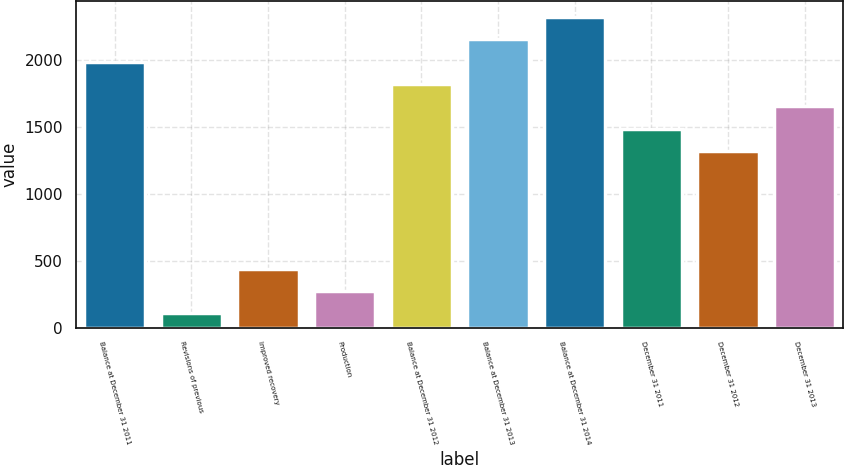Convert chart to OTSL. <chart><loc_0><loc_0><loc_500><loc_500><bar_chart><fcel>Balance at December 31 2011<fcel>Revisions of previous<fcel>Improved recovery<fcel>Production<fcel>Balance at December 31 2012<fcel>Balance at December 31 2013<fcel>Balance at December 31 2014<fcel>December 31 2011<fcel>December 31 2012<fcel>December 31 2013<nl><fcel>1991<fcel>107<fcel>441.8<fcel>274.4<fcel>1823.6<fcel>2158.4<fcel>2325.8<fcel>1488.8<fcel>1321.4<fcel>1656.2<nl></chart> 